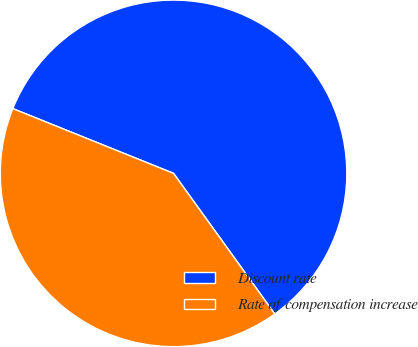Convert chart. <chart><loc_0><loc_0><loc_500><loc_500><pie_chart><fcel>Discount rate<fcel>Rate of compensation increase<nl><fcel>58.97%<fcel>41.03%<nl></chart> 